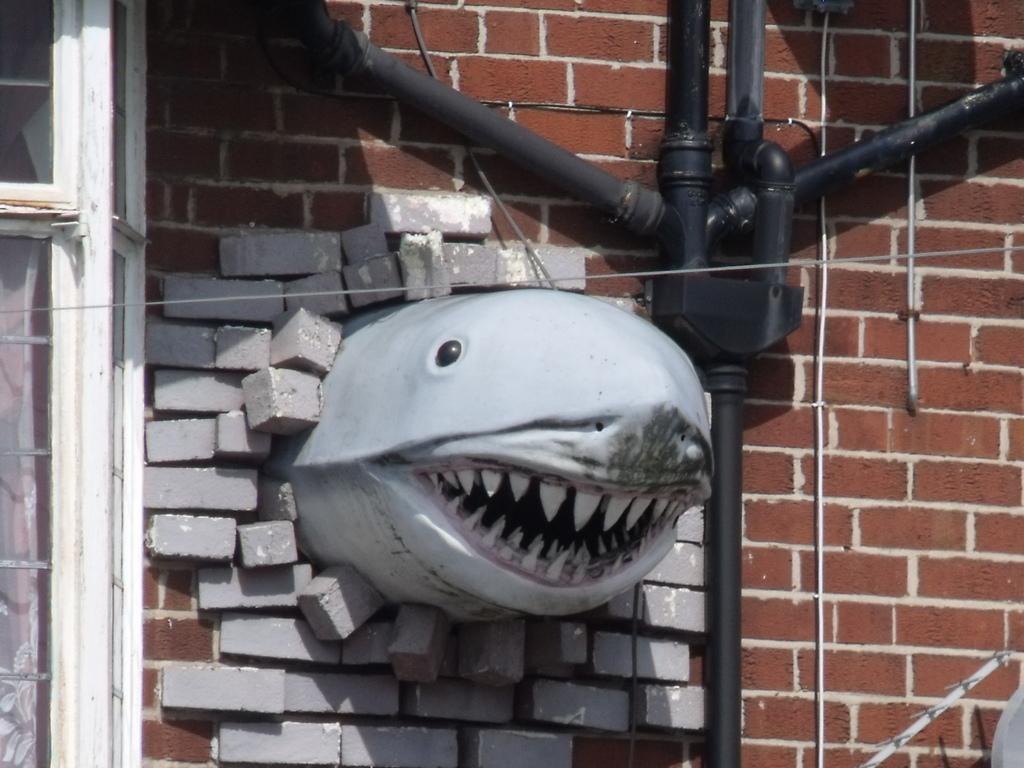In one or two sentences, can you explain what this image depicts? In the picture I can see the statue of a water animal in the middle of the image. I can see the pipelines on the brick wall. I can see the glass windows on the left side of the picture. 